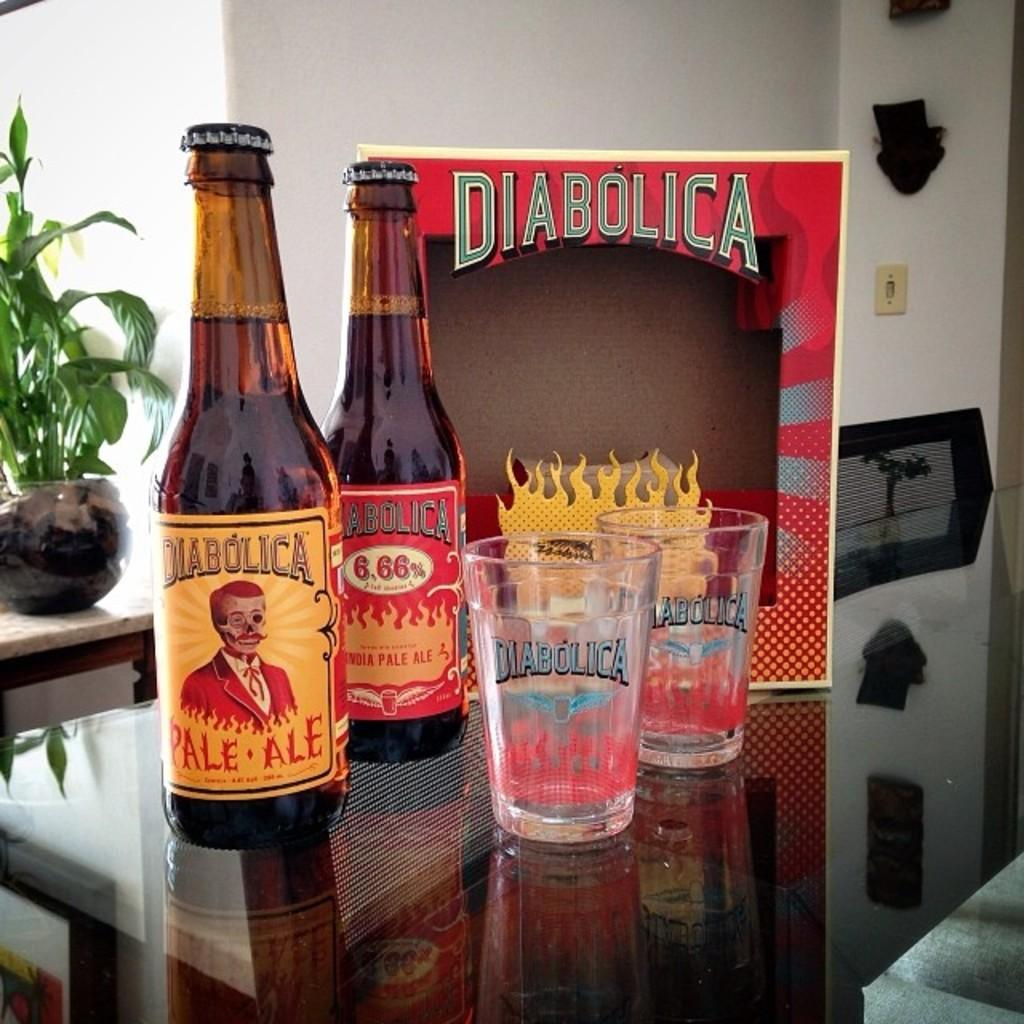How many bottles are on the table in the image? There are two bottles on the table in the image. What else is on the table besides the bottles? There are glasses and a frame on the table. What type of furniture is in the image? There is a chair in the image. What kind of vegetation is present in the image? There is a plant in the image. What can be seen in the background of the image? There is a wall in the background of the image. How many rabbits are hopping around the plant in the image? There are no rabbits present in the image; only a plant is visible. What type of snake can be seen slithering on the wall in the background? There is no snake present in the image; only a wall is visible in the background. 